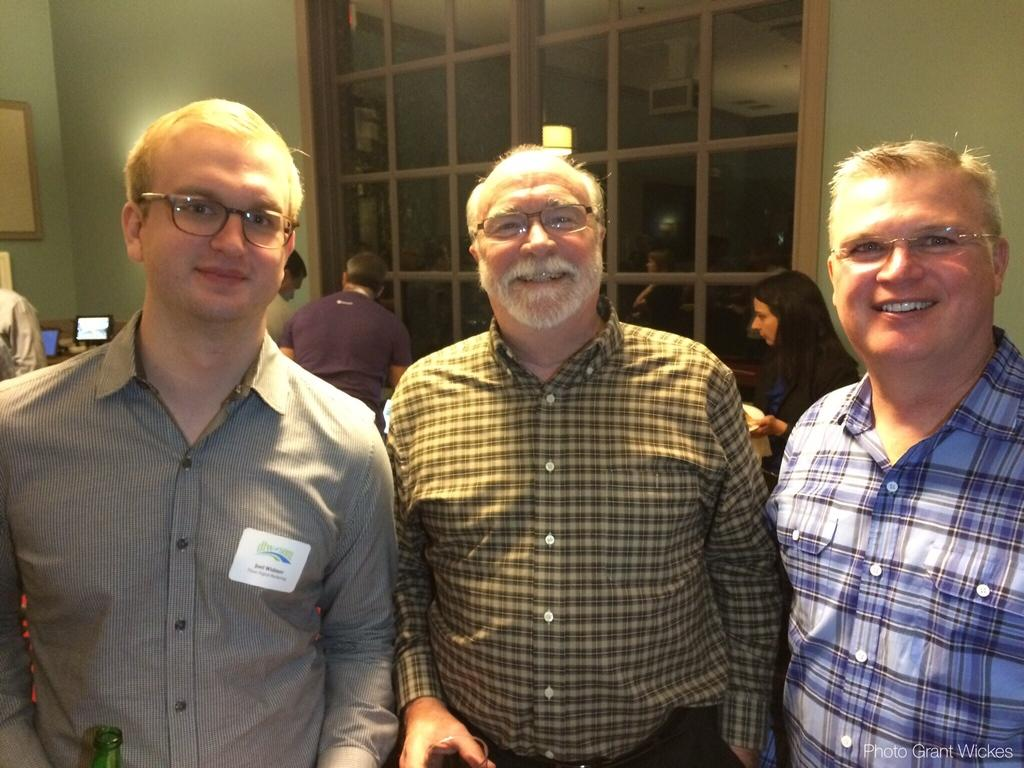What are the people in the image doing? The people in the image are standing. Can you describe the expressions on the faces of some of the people? Some of the people are smiling. What can be seen in the background of the image? There are desktops visible in the background of the image. What is the riddle that the people are trying to solve in the image? There is no riddle present in the image; the people are simply standing and smiling. 